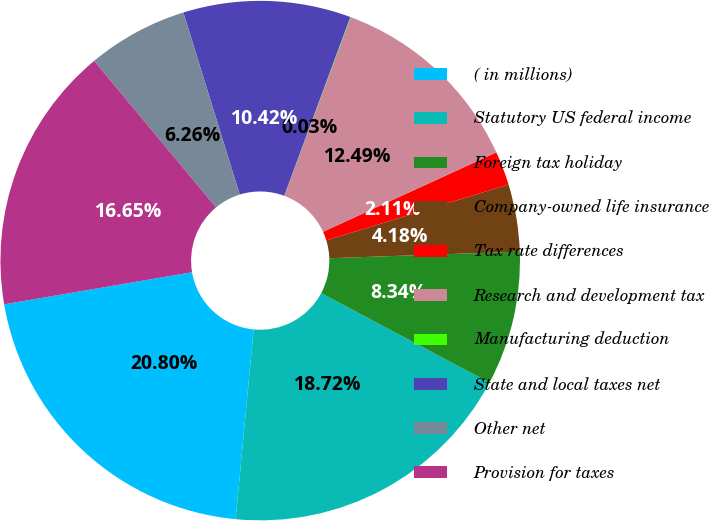Convert chart. <chart><loc_0><loc_0><loc_500><loc_500><pie_chart><fcel>( in millions)<fcel>Statutory US federal income<fcel>Foreign tax holiday<fcel>Company-owned life insurance<fcel>Tax rate differences<fcel>Research and development tax<fcel>Manufacturing deduction<fcel>State and local taxes net<fcel>Other net<fcel>Provision for taxes<nl><fcel>20.8%<fcel>18.72%<fcel>8.34%<fcel>4.18%<fcel>2.11%<fcel>12.49%<fcel>0.03%<fcel>10.42%<fcel>6.26%<fcel>16.65%<nl></chart> 